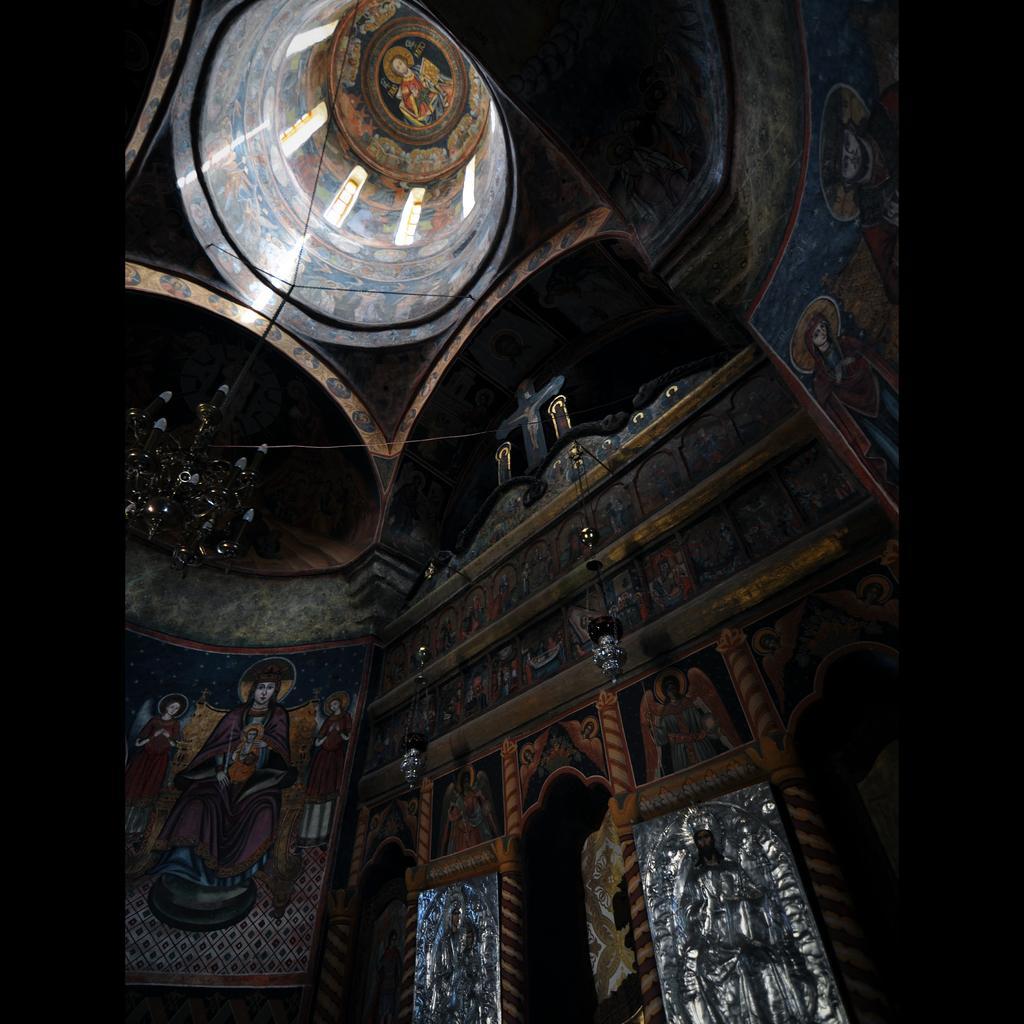How would you summarize this image in a sentence or two? In this image we can see inside of a building. We can see the paintings on the wall. There are few sculptures in the image. 